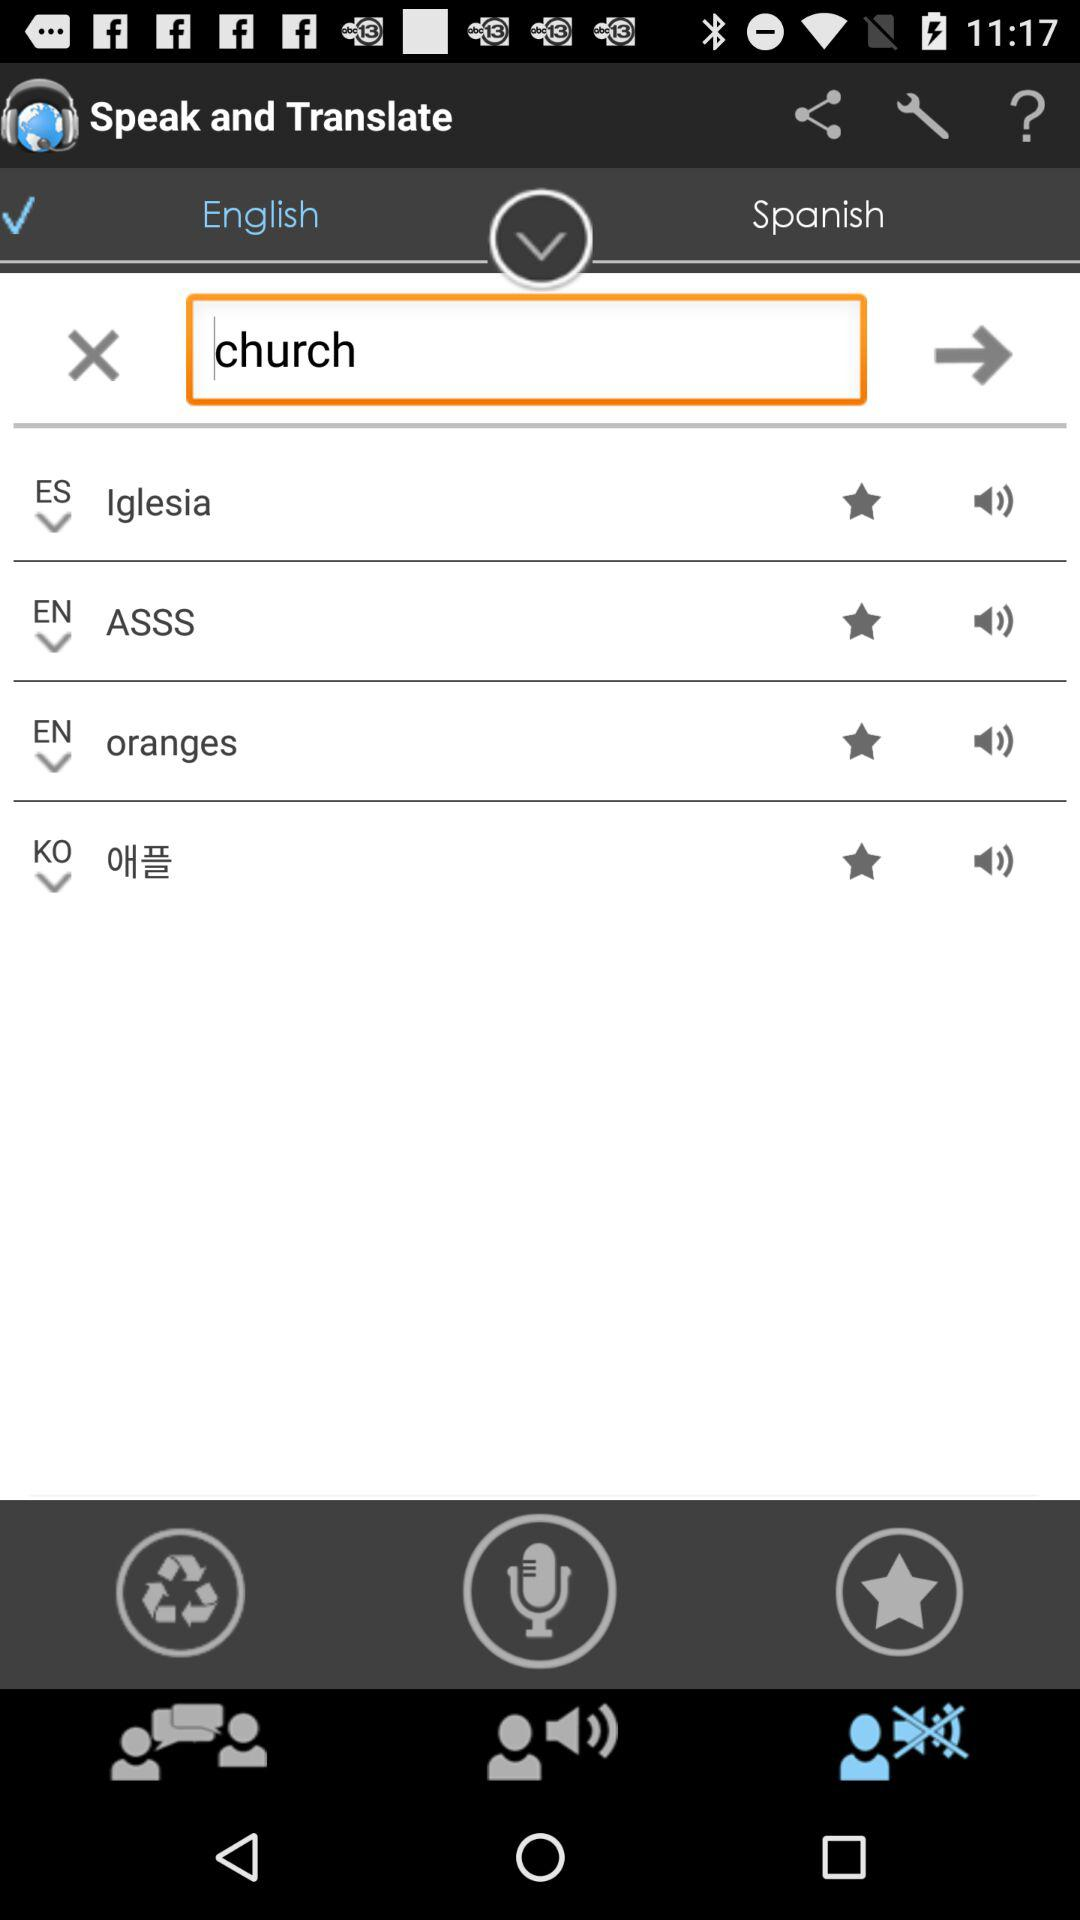What is the selected language? The selected language is English. 